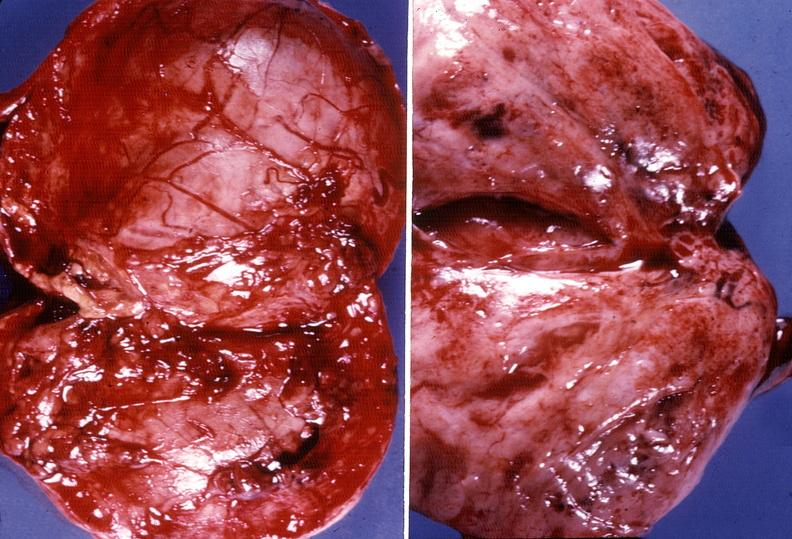what is present?
Answer the question using a single word or phrase. Endocrine 